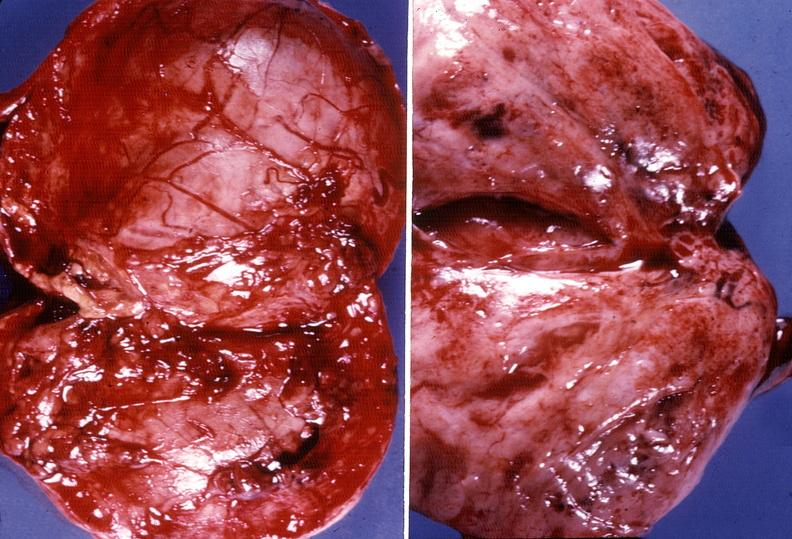what is present?
Answer the question using a single word or phrase. Endocrine 